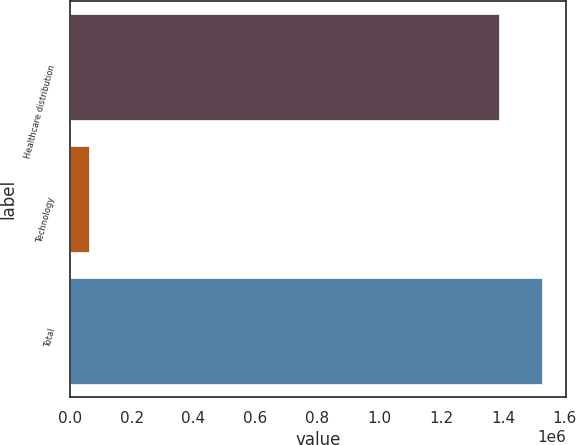Convert chart to OTSL. <chart><loc_0><loc_0><loc_500><loc_500><bar_chart><fcel>Healthcare distribution<fcel>Technology<fcel>Total<nl><fcel>1.38758e+06<fcel>62134<fcel>1.52634e+06<nl></chart> 